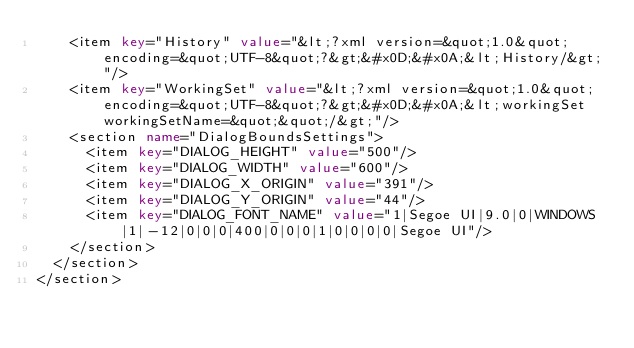Convert code to text. <code><loc_0><loc_0><loc_500><loc_500><_XML_>		<item key="History" value="&lt;?xml version=&quot;1.0&quot; encoding=&quot;UTF-8&quot;?&gt;&#x0D;&#x0A;&lt;History/&gt;"/>
		<item key="WorkingSet" value="&lt;?xml version=&quot;1.0&quot; encoding=&quot;UTF-8&quot;?&gt;&#x0D;&#x0A;&lt;workingSet workingSetName=&quot;&quot;/&gt;"/>
		<section name="DialogBoundsSettings">
			<item key="DIALOG_HEIGHT" value="500"/>
			<item key="DIALOG_WIDTH" value="600"/>
			<item key="DIALOG_X_ORIGIN" value="391"/>
			<item key="DIALOG_Y_ORIGIN" value="44"/>
			<item key="DIALOG_FONT_NAME" value="1|Segoe UI|9.0|0|WINDOWS|1|-12|0|0|0|400|0|0|0|1|0|0|0|0|Segoe UI"/>
		</section>
	</section>
</section>
</code> 